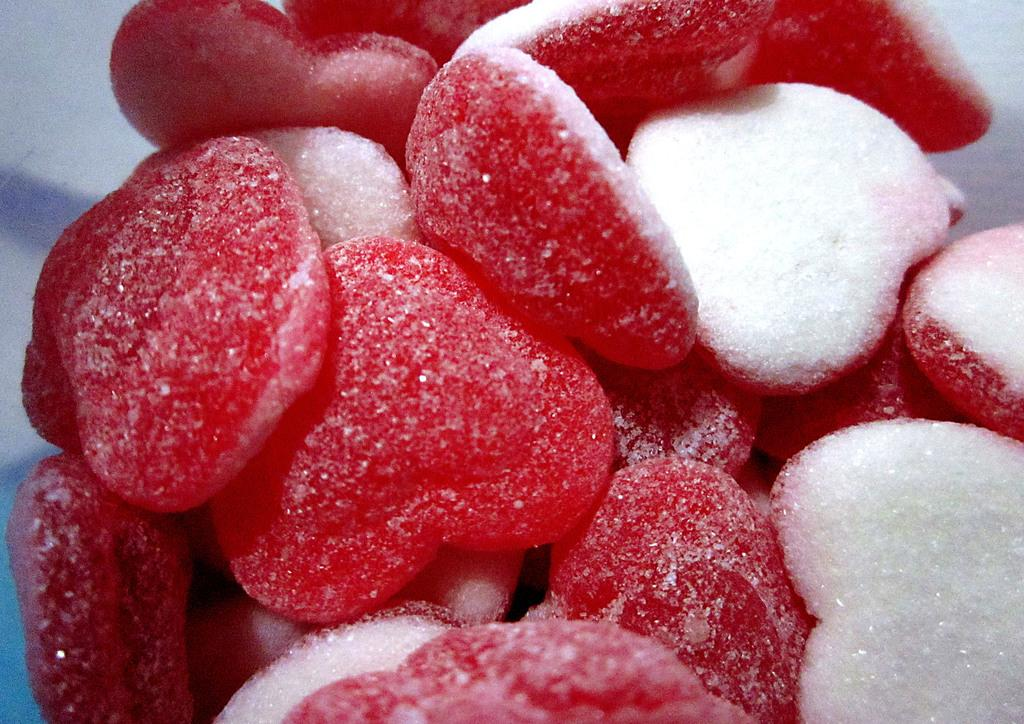What type of candies are present in the image? There are red sugar candies in the image. Where is the faucet located in the image? There is no faucet present in the image; it only features red sugar candies. What order are the candies arranged in the image? The provided facts do not give information about the arrangement of the candies, so we cannot determine the order in which they are arranged. 